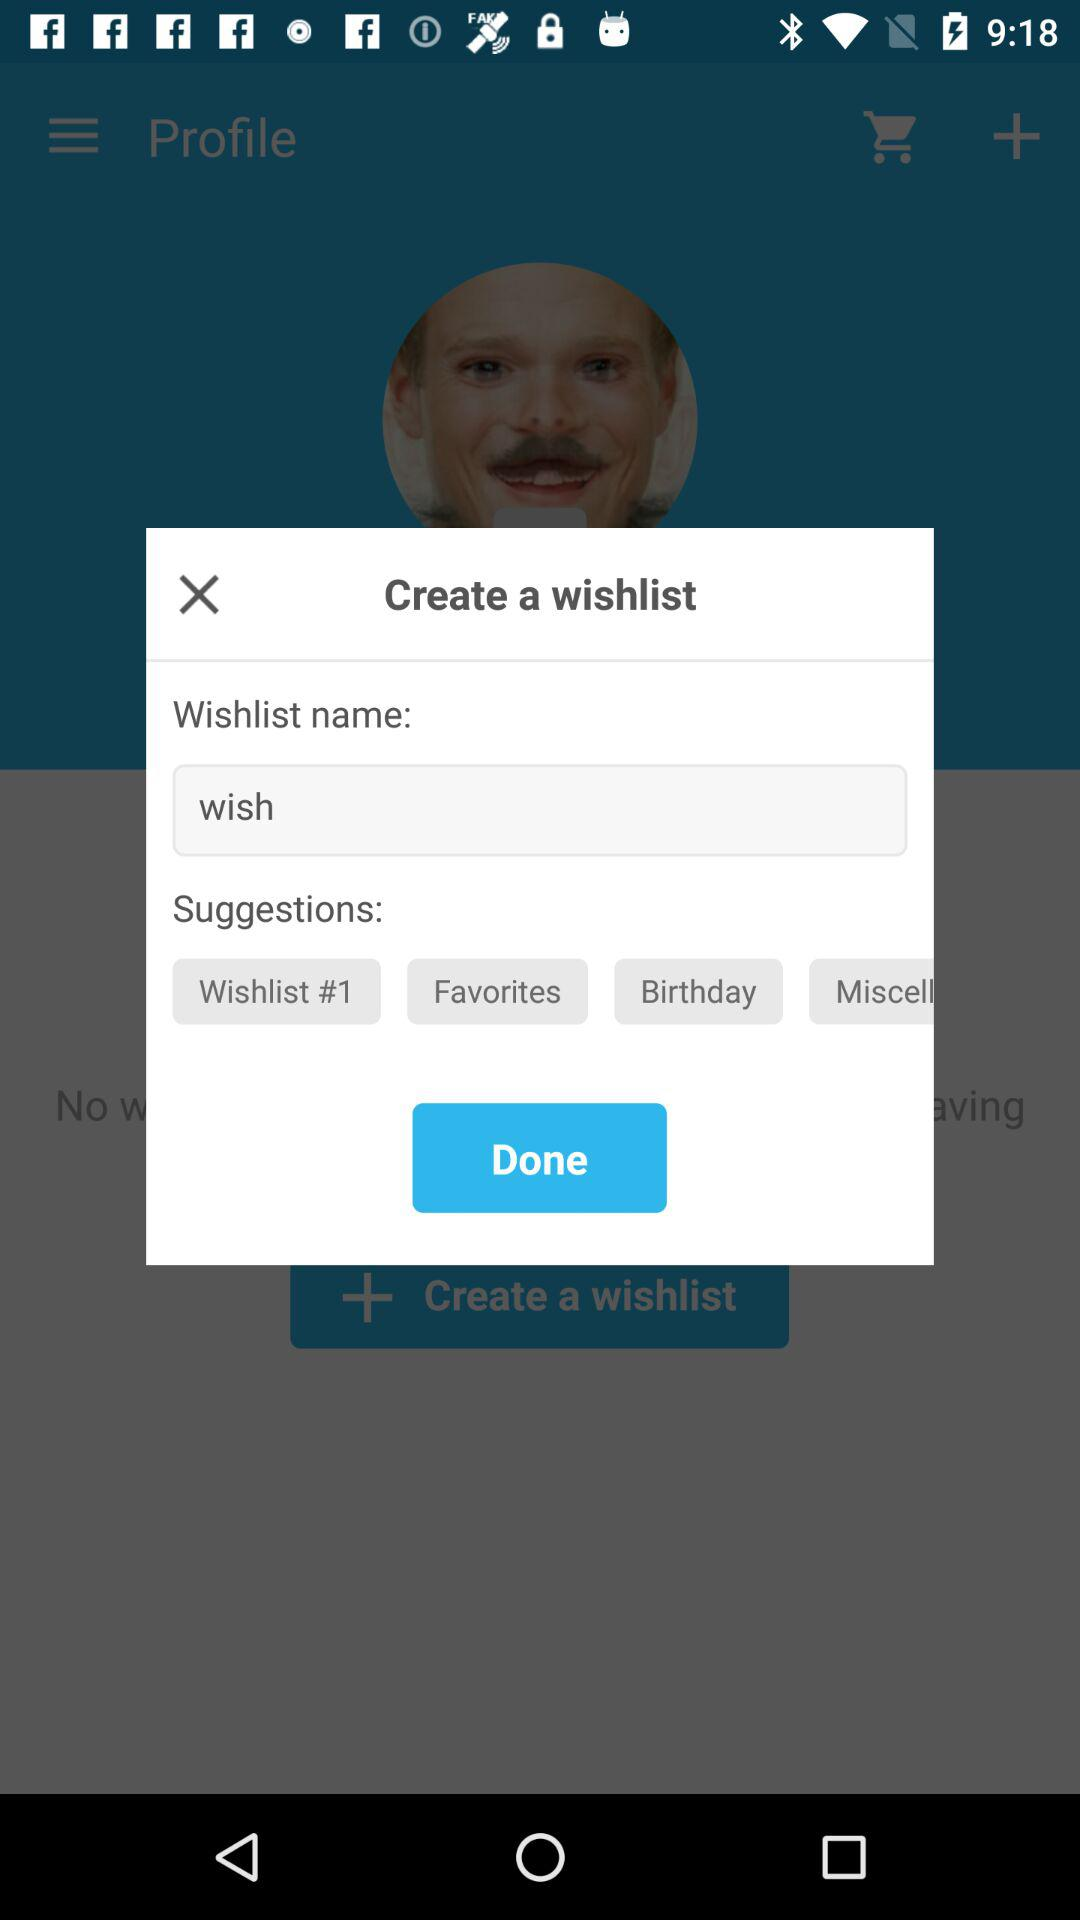What is the name of the wishlist? The name of the wishlist is "wish". 